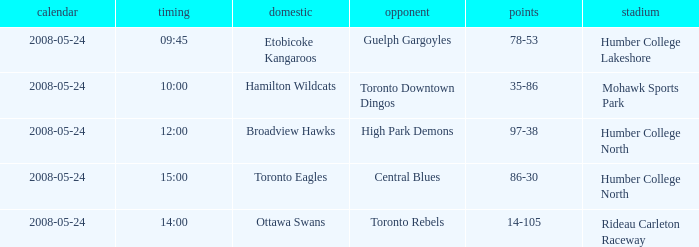On which basis did the away team of the toronto rebels compete? Rideau Carleton Raceway. 